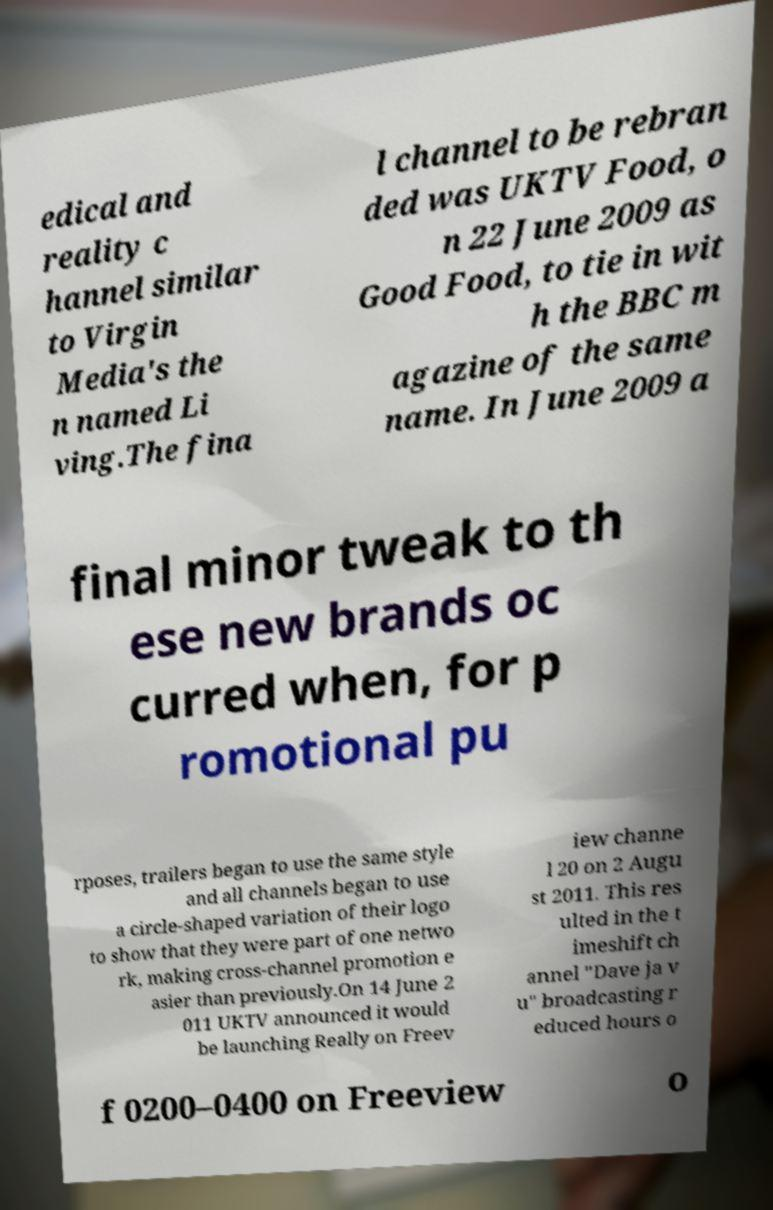Please identify and transcribe the text found in this image. edical and reality c hannel similar to Virgin Media's the n named Li ving.The fina l channel to be rebran ded was UKTV Food, o n 22 June 2009 as Good Food, to tie in wit h the BBC m agazine of the same name. In June 2009 a final minor tweak to th ese new brands oc curred when, for p romotional pu rposes, trailers began to use the same style and all channels began to use a circle-shaped variation of their logo to show that they were part of one netwo rk, making cross-channel promotion e asier than previously.On 14 June 2 011 UKTV announced it would be launching Really on Freev iew channe l 20 on 2 Augu st 2011. This res ulted in the t imeshift ch annel "Dave ja v u" broadcasting r educed hours o f 0200–0400 on Freeview o 